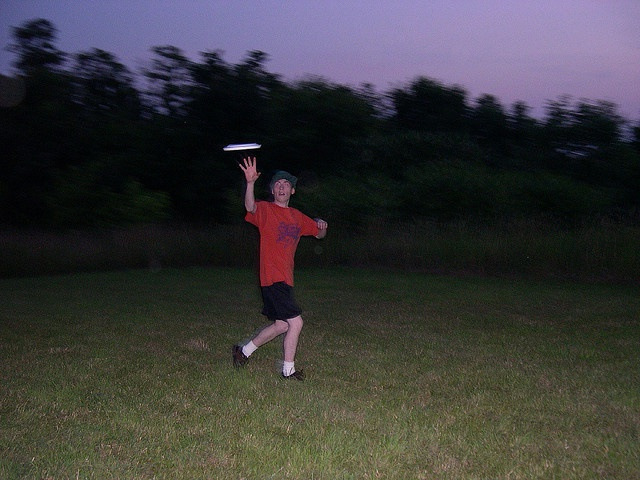Describe the objects in this image and their specific colors. I can see people in blue, black, brown, maroon, and gray tones and frisbee in blue, lavender, darkgray, and gray tones in this image. 